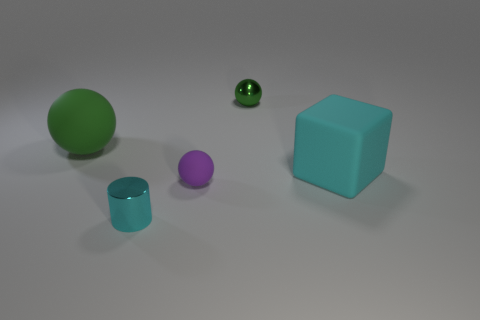Subtract all blue blocks. How many green balls are left? 2 Subtract all rubber spheres. How many spheres are left? 1 Subtract 1 balls. How many balls are left? 2 Add 3 tiny balls. How many objects exist? 8 Subtract all blue spheres. Subtract all red cylinders. How many spheres are left? 3 Subtract all spheres. How many objects are left? 2 Subtract 1 green balls. How many objects are left? 4 Subtract all cyan rubber things. Subtract all large matte balls. How many objects are left? 3 Add 1 metallic objects. How many metallic objects are left? 3 Add 2 yellow rubber spheres. How many yellow rubber spheres exist? 2 